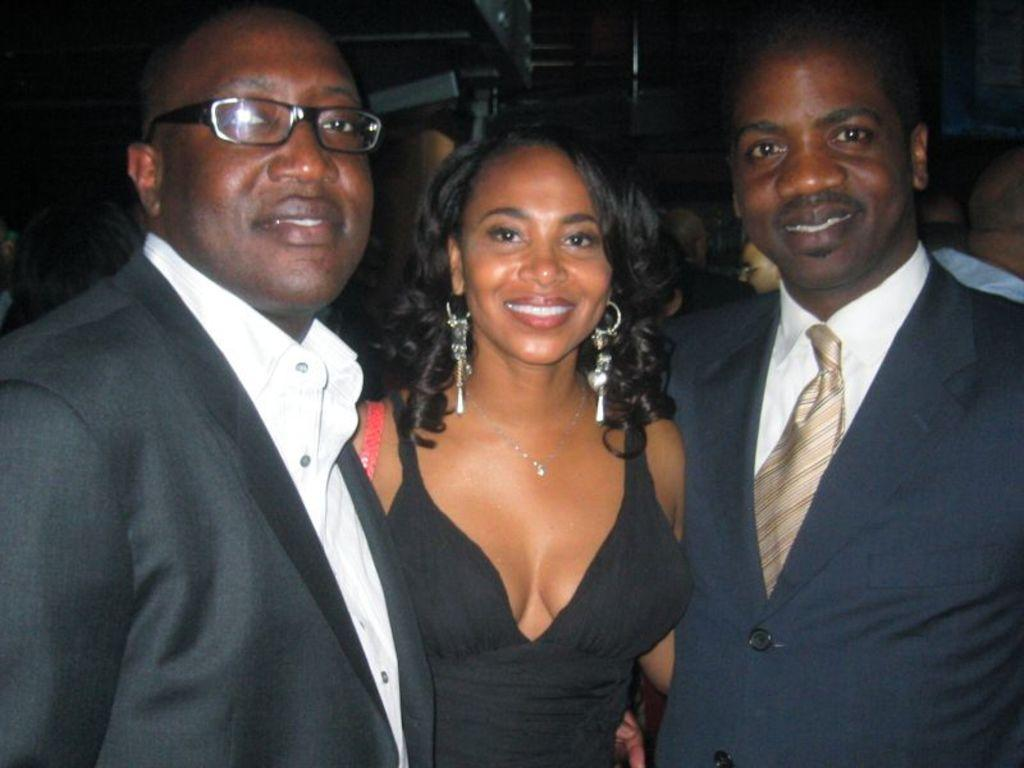How many men are in the image? There are two men in the image. What are the men wearing? The men are wearing blazers. What is the woman in the image doing? The woman is smiling. What are the men in the image doing? The men are smiling. Can you describe the people visible in the background of the image? There are people visible in the background of the image, but their specific actions or appearances are not mentioned in the provided facts. What type of expansion is taking place in the image? There is no mention of any expansion in the image; it features two men wearing blazers, a smiling woman, and people in the background. Can you tell me what is inside the locket the woman is wearing in the image? There is no mention of a locket in the image; the woman is simply smiling. 